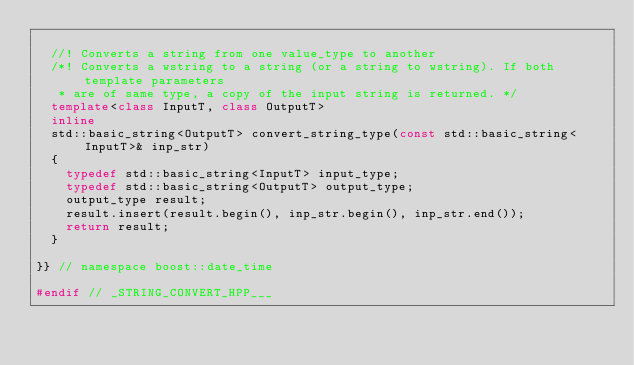<code> <loc_0><loc_0><loc_500><loc_500><_C++_>
  //! Converts a string from one value_type to another
  /*! Converts a wstring to a string (or a string to wstring). If both template parameters 
   * are of same type, a copy of the input string is returned. */
  template<class InputT, class OutputT>
  inline
  std::basic_string<OutputT> convert_string_type(const std::basic_string<InputT>& inp_str)
  {
    typedef std::basic_string<InputT> input_type;
    typedef std::basic_string<OutputT> output_type;
    output_type result;
    result.insert(result.begin(), inp_str.begin(), inp_str.end());
    return result;
  }
  
}} // namespace boost::date_time

#endif // _STRING_CONVERT_HPP___
</code> 